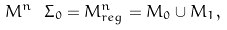Convert formula to latex. <formula><loc_0><loc_0><loc_500><loc_500>M ^ { n } \ \Sigma _ { 0 } = M ^ { n } _ { r e g } = M _ { 0 } \cup M _ { 1 } ,</formula> 